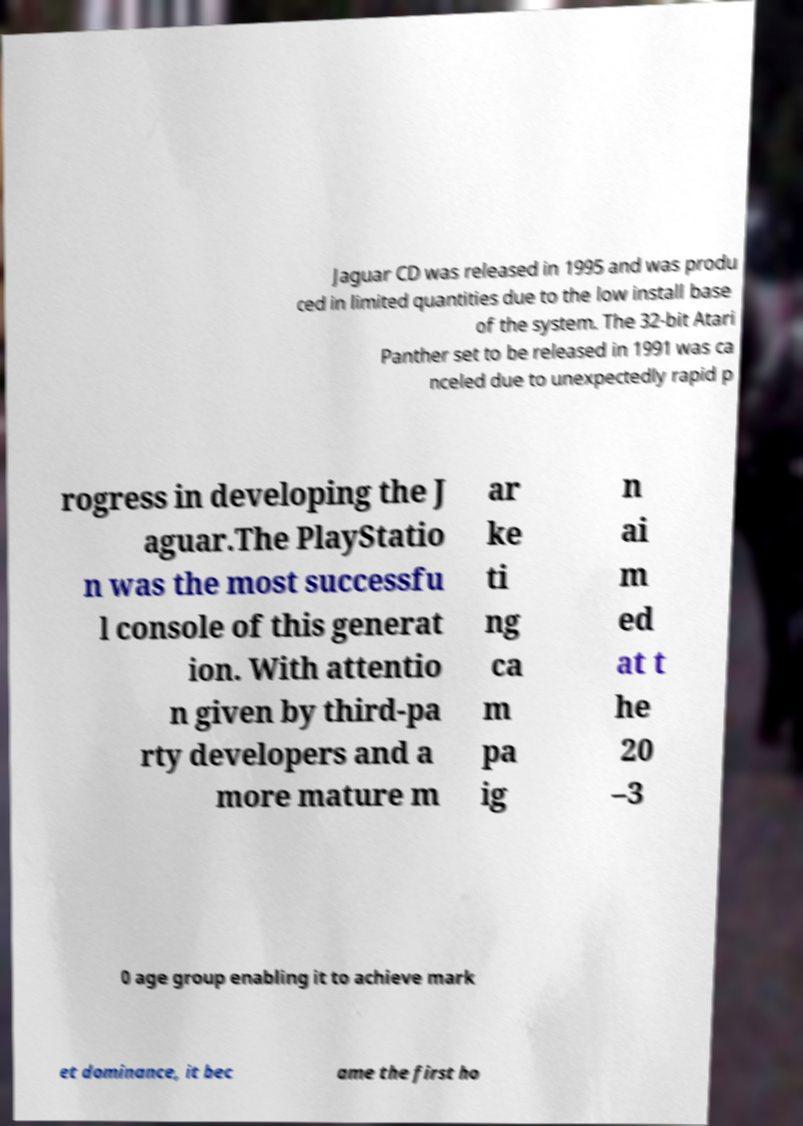Could you extract and type out the text from this image? Jaguar CD was released in 1995 and was produ ced in limited quantities due to the low install base of the system. The 32-bit Atari Panther set to be released in 1991 was ca nceled due to unexpectedly rapid p rogress in developing the J aguar.The PlayStatio n was the most successfu l console of this generat ion. With attentio n given by third-pa rty developers and a more mature m ar ke ti ng ca m pa ig n ai m ed at t he 20 –3 0 age group enabling it to achieve mark et dominance, it bec ame the first ho 